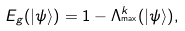<formula> <loc_0><loc_0><loc_500><loc_500>E _ { g } ( | { \psi \rangle ) } = 1 - \Lambda _ { ^ { \max } } ^ { k } ( | { \psi \rangle ) } ,</formula> 